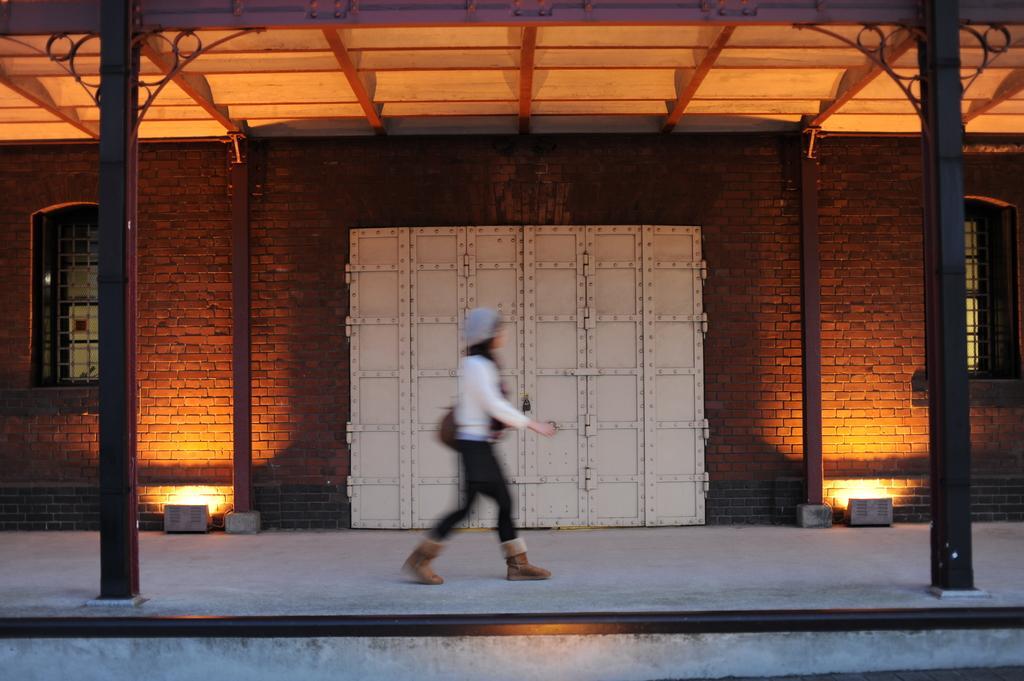Can you describe this image briefly? In the Image, we can see a person whose picture is blurred and the person is wearing a white top and a black jeans. In the background we can see a red colored brick wall and there are lights and windows on the either sides. 